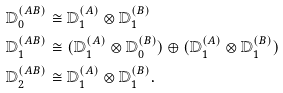Convert formula to latex. <formula><loc_0><loc_0><loc_500><loc_500>\mathbb { D } _ { 0 } ^ { ( A B ) } & \cong \mathbb { D } _ { 1 } ^ { ( A ) } \otimes \mathbb { D } _ { 1 } ^ { ( B ) } \\ \mathbb { D } _ { 1 } ^ { ( A B ) } & \cong ( \mathbb { D } _ { 1 } ^ { ( A ) } \otimes \mathbb { D } _ { 0 } ^ { ( B ) } ) \oplus ( \mathbb { D } _ { 1 } ^ { ( A ) } \otimes \mathbb { D } _ { 1 } ^ { ( B ) } ) \\ \mathbb { D } _ { 2 } ^ { ( A B ) } & \cong \mathbb { D } _ { 1 } ^ { ( A ) } \otimes \mathbb { D } _ { 1 } ^ { ( B ) } .</formula> 